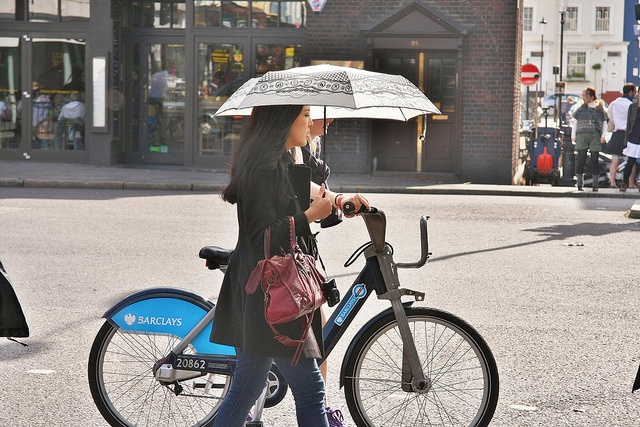Describe the objects in this image and their specific colors. I can see bicycle in darkgray, lightgray, black, and gray tones, people in darkgray, black, and gray tones, umbrella in darkgray, lightgray, gray, and black tones, handbag in darkgray, brown, maroon, and black tones, and people in darkgray, gray, black, and lightgray tones in this image. 